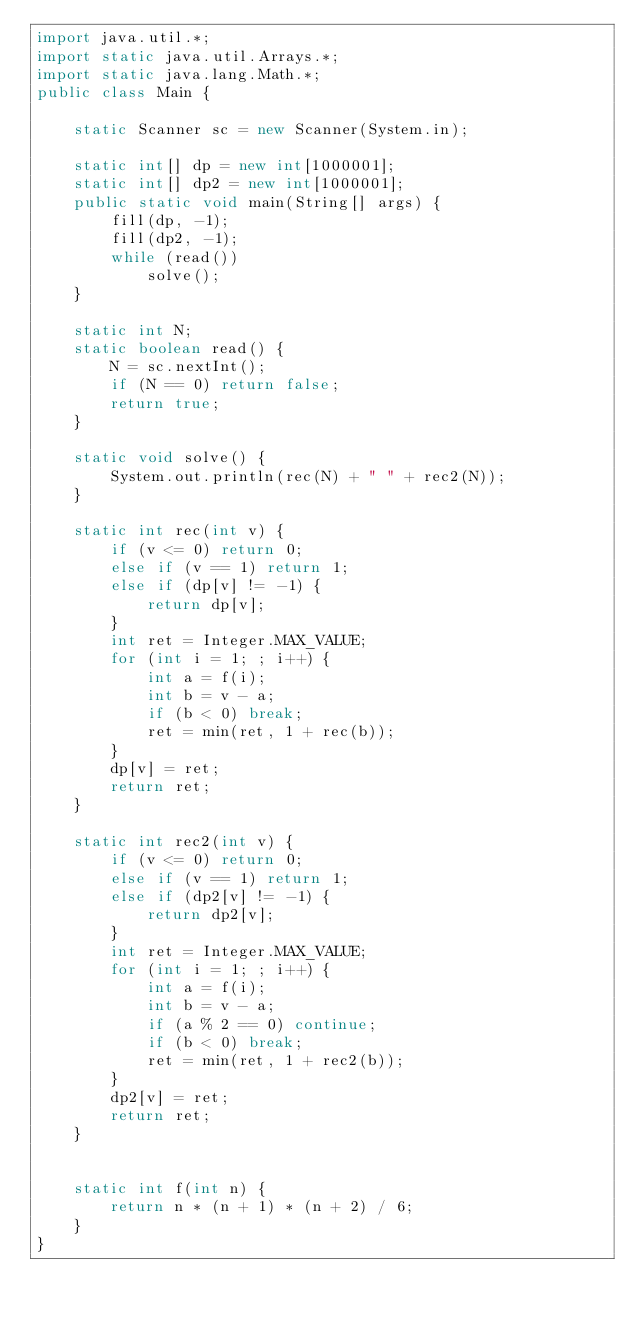Convert code to text. <code><loc_0><loc_0><loc_500><loc_500><_Java_>import java.util.*;
import static java.util.Arrays.*;
import static java.lang.Math.*;
public class Main {

	static Scanner sc = new Scanner(System.in);
	
	static int[] dp = new int[1000001];
	static int[] dp2 = new int[1000001];
	public static void main(String[] args) {
		fill(dp, -1);
		fill(dp2, -1);
		while (read())
			solve();
	}
	
	static int N;
	static boolean read() {
		N = sc.nextInt();
		if (N == 0) return false;
		return true;
	}

	static void solve() {
		System.out.println(rec(N) + " " + rec2(N));
	}
	
	static int rec(int v) {
		if (v <= 0) return 0;
		else if (v == 1) return 1;
		else if (dp[v] != -1) {
			return dp[v];
		}
		int ret = Integer.MAX_VALUE;
		for (int i = 1; ; i++) {
			int a = f(i);
			int b = v - a;
			if (b < 0) break;
			ret = min(ret, 1 + rec(b));
		}
		dp[v] = ret;
		return ret;
	}
	
	static int rec2(int v) {
		if (v <= 0) return 0;
		else if (v == 1) return 1;
		else if (dp2[v] != -1) {
			return dp2[v];
		}
		int ret = Integer.MAX_VALUE;
		for (int i = 1; ; i++) {
			int a = f(i);
			int b = v - a;
			if (a % 2 == 0) continue;
			if (b < 0) break;
			ret = min(ret, 1 + rec2(b));
		}
		dp2[v] = ret;
		return ret;
	}


	static int f(int n) {
		return n * (n + 1) * (n + 2) / 6;
	}
}</code> 